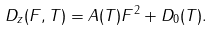<formula> <loc_0><loc_0><loc_500><loc_500>D _ { z } ( F , T ) = A ( T ) F ^ { 2 } + D _ { 0 } ( T ) .</formula> 